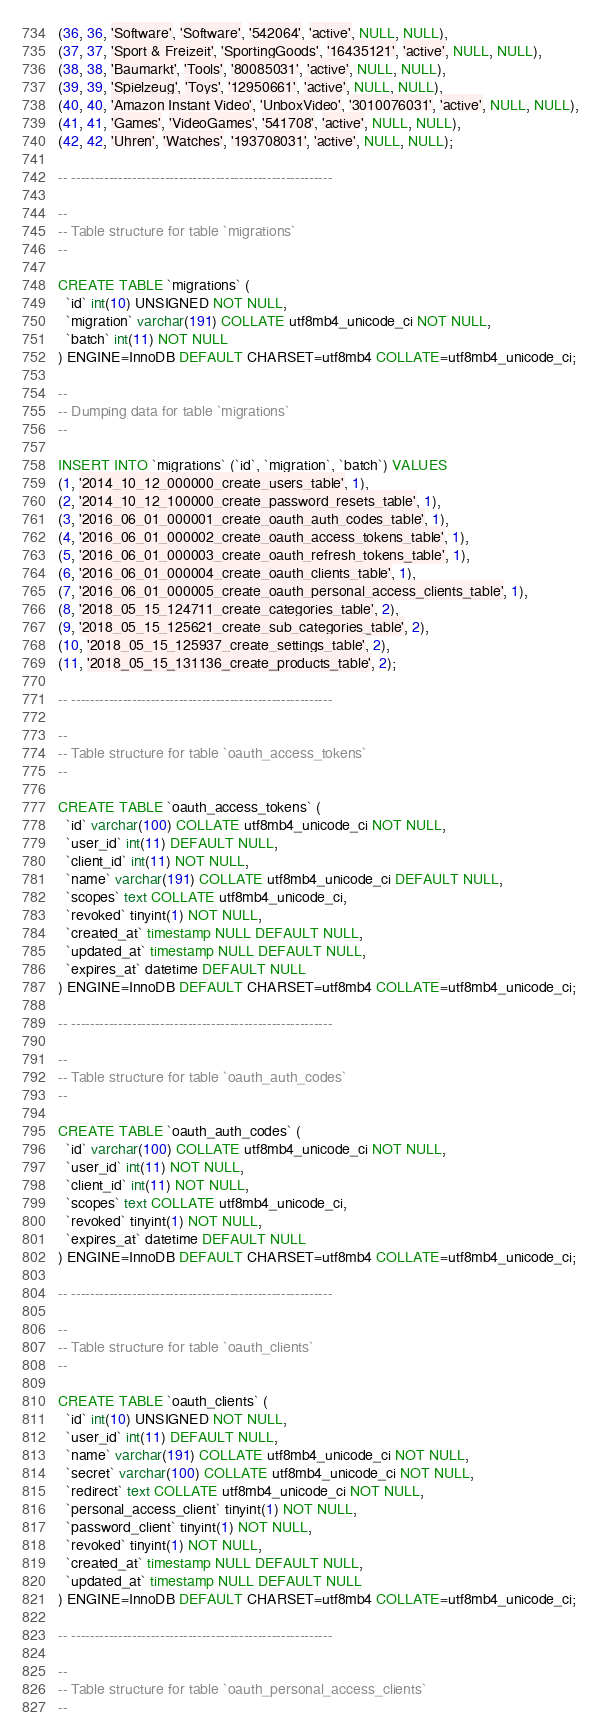<code> <loc_0><loc_0><loc_500><loc_500><_SQL_>(36, 36, 'Software', 'Software', '542064', 'active', NULL, NULL),
(37, 37, 'Sport & Freizeit', 'SportingGoods', '16435121', 'active', NULL, NULL),
(38, 38, 'Baumarkt', 'Tools', '80085031', 'active', NULL, NULL),
(39, 39, 'Spielzeug', 'Toys', '12950661', 'active', NULL, NULL),
(40, 40, 'Amazon Instant Video', 'UnboxVideo', '3010076031', 'active', NULL, NULL),
(41, 41, 'Games', 'VideoGames', '541708', 'active', NULL, NULL),
(42, 42, 'Uhren', 'Watches', '193708031', 'active', NULL, NULL);

-- --------------------------------------------------------

--
-- Table structure for table `migrations`
--

CREATE TABLE `migrations` (
  `id` int(10) UNSIGNED NOT NULL,
  `migration` varchar(191) COLLATE utf8mb4_unicode_ci NOT NULL,
  `batch` int(11) NOT NULL
) ENGINE=InnoDB DEFAULT CHARSET=utf8mb4 COLLATE=utf8mb4_unicode_ci;

--
-- Dumping data for table `migrations`
--

INSERT INTO `migrations` (`id`, `migration`, `batch`) VALUES
(1, '2014_10_12_000000_create_users_table', 1),
(2, '2014_10_12_100000_create_password_resets_table', 1),
(3, '2016_06_01_000001_create_oauth_auth_codes_table', 1),
(4, '2016_06_01_000002_create_oauth_access_tokens_table', 1),
(5, '2016_06_01_000003_create_oauth_refresh_tokens_table', 1),
(6, '2016_06_01_000004_create_oauth_clients_table', 1),
(7, '2016_06_01_000005_create_oauth_personal_access_clients_table', 1),
(8, '2018_05_15_124711_create_categories_table', 2),
(9, '2018_05_15_125621_create_sub_categories_table', 2),
(10, '2018_05_15_125937_create_settings_table', 2),
(11, '2018_05_15_131136_create_products_table', 2);

-- --------------------------------------------------------

--
-- Table structure for table `oauth_access_tokens`
--

CREATE TABLE `oauth_access_tokens` (
  `id` varchar(100) COLLATE utf8mb4_unicode_ci NOT NULL,
  `user_id` int(11) DEFAULT NULL,
  `client_id` int(11) NOT NULL,
  `name` varchar(191) COLLATE utf8mb4_unicode_ci DEFAULT NULL,
  `scopes` text COLLATE utf8mb4_unicode_ci,
  `revoked` tinyint(1) NOT NULL,
  `created_at` timestamp NULL DEFAULT NULL,
  `updated_at` timestamp NULL DEFAULT NULL,
  `expires_at` datetime DEFAULT NULL
) ENGINE=InnoDB DEFAULT CHARSET=utf8mb4 COLLATE=utf8mb4_unicode_ci;

-- --------------------------------------------------------

--
-- Table structure for table `oauth_auth_codes`
--

CREATE TABLE `oauth_auth_codes` (
  `id` varchar(100) COLLATE utf8mb4_unicode_ci NOT NULL,
  `user_id` int(11) NOT NULL,
  `client_id` int(11) NOT NULL,
  `scopes` text COLLATE utf8mb4_unicode_ci,
  `revoked` tinyint(1) NOT NULL,
  `expires_at` datetime DEFAULT NULL
) ENGINE=InnoDB DEFAULT CHARSET=utf8mb4 COLLATE=utf8mb4_unicode_ci;

-- --------------------------------------------------------

--
-- Table structure for table `oauth_clients`
--

CREATE TABLE `oauth_clients` (
  `id` int(10) UNSIGNED NOT NULL,
  `user_id` int(11) DEFAULT NULL,
  `name` varchar(191) COLLATE utf8mb4_unicode_ci NOT NULL,
  `secret` varchar(100) COLLATE utf8mb4_unicode_ci NOT NULL,
  `redirect` text COLLATE utf8mb4_unicode_ci NOT NULL,
  `personal_access_client` tinyint(1) NOT NULL,
  `password_client` tinyint(1) NOT NULL,
  `revoked` tinyint(1) NOT NULL,
  `created_at` timestamp NULL DEFAULT NULL,
  `updated_at` timestamp NULL DEFAULT NULL
) ENGINE=InnoDB DEFAULT CHARSET=utf8mb4 COLLATE=utf8mb4_unicode_ci;

-- --------------------------------------------------------

--
-- Table structure for table `oauth_personal_access_clients`
--
</code> 